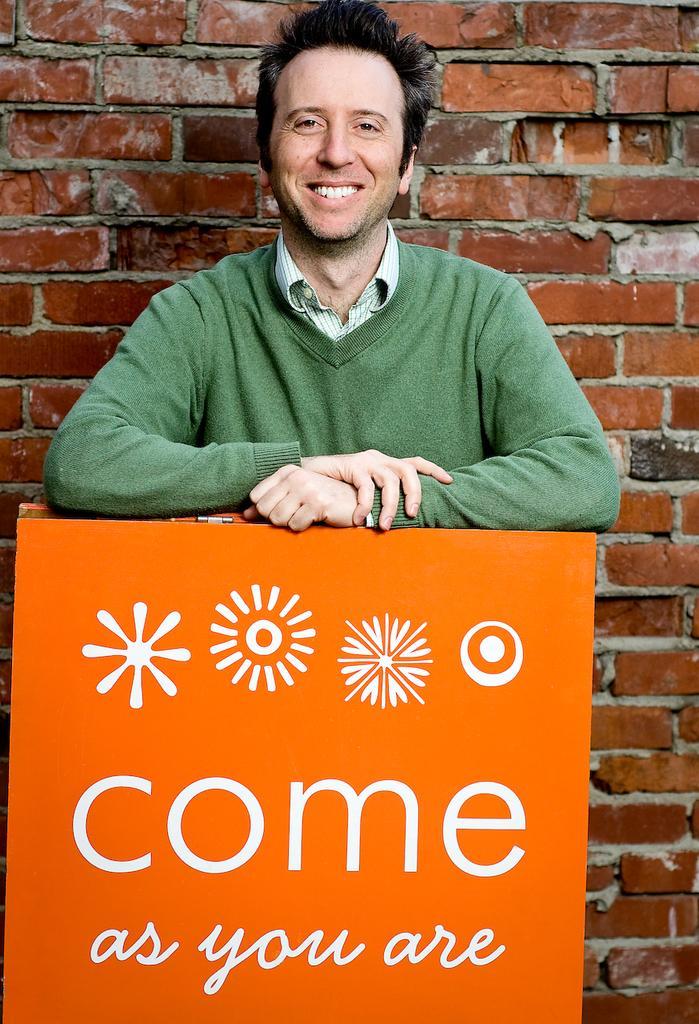In one or two sentences, can you explain what this image depicts? In this image I can see the person is standing in front of the orange color object and I can see something is written on it with white color. I can see the brick wall. 